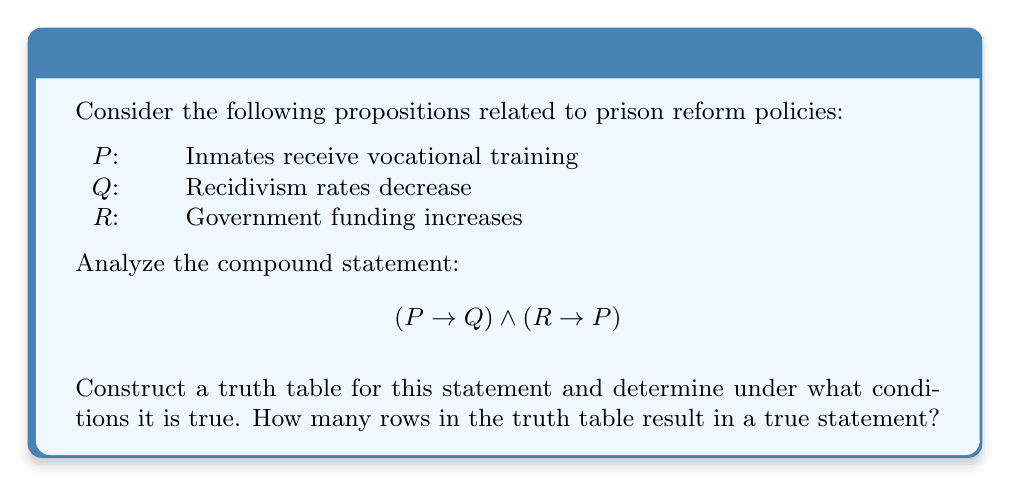What is the answer to this math problem? Let's approach this step-by-step:

1) First, we need to construct a truth table with all possible combinations of P, Q, and R. There will be $2^3 = 8$ rows.

2) Next, we'll evaluate $(P \rightarrow Q)$ and $(R \rightarrow P)$ separately, then combine them with the AND operator $\land$.

3) Here's the truth table:

   $$\begin{array}{|c|c|c|c|c|c|c|}
   \hline
   P & Q & R & P \rightarrow Q & R \rightarrow P & (P \rightarrow Q) \land (R \rightarrow P) \\
   \hline
   T & T & T & T & T & T \\
   T & T & F & T & T & T \\
   T & F & T & F & T & F \\
   T & F & F & F & T & F \\
   F & T & T & T & F & F \\
   F & T & F & T & T & T \\
   F & F & T & T & F & F \\
   F & F & F & T & T & T \\
   \hline
   \end{array}$$

4) Remember:
   - $P \rightarrow Q$ is false only when P is true and Q is false.
   - $R \rightarrow P$ is false only when R is true and P is false.

5) The compound statement $(P \rightarrow Q) \land (R \rightarrow P)$ is true only when both individual conditionals are true.

6) Counting the true results in the final column, we see that the statement is true in 4 out of the 8 possible combinations.

This result suggests that the compound statement about vocational training leading to decreased recidivism and increased funding leading to vocational training is true in half of all possible scenarios.
Answer: 4 rows 